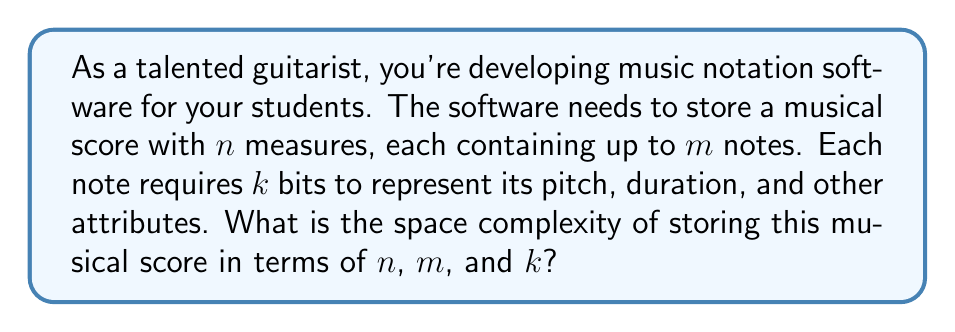Show me your answer to this math problem. To analyze the space complexity of storing a musical score, let's break down the problem step-by-step:

1. We have $n$ measures in the score.
2. Each measure can contain up to $m$ notes.
3. Each note requires $k$ bits to store its information.

To calculate the total space required:

1. Space for one note: $k$ bits
2. Space for one measure: Up to $m$ notes, so $m \cdot k$ bits
3. Space for the entire score: $n$ measures, so $n \cdot (m \cdot k)$ bits

Simplifying:
$$ \text{Total space} = n \cdot m \cdot k \text{ bits} $$

In Big O notation, we express this as $O(nmk)$.

This represents the worst-case scenario where every measure contains the maximum number of notes. In practice, some measures might have fewer notes, but for space complexity analysis, we consider the upper bound.

It's worth noting that this analysis assumes a simple representation. In a more sophisticated system, there might be additional overhead for storing measure boundaries, time signatures, or other musical notations. However, these would typically add a constant factor or at most a linear factor in $n$, which wouldn't change the overall complexity class.
Answer: The space complexity of storing the musical score is $O(nmk)$. 